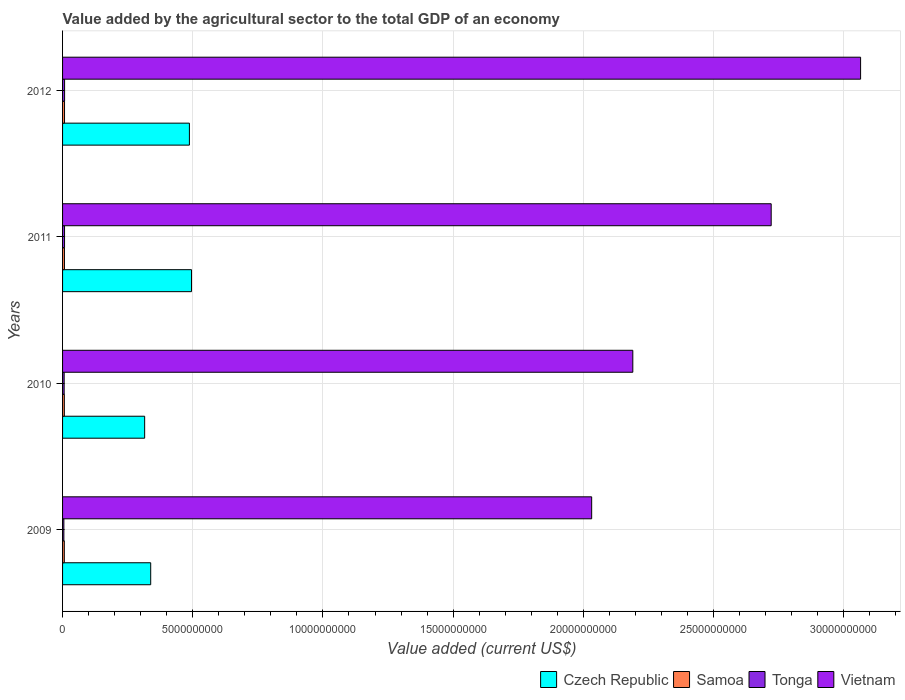How many different coloured bars are there?
Ensure brevity in your answer.  4. How many bars are there on the 3rd tick from the bottom?
Provide a succinct answer. 4. In how many cases, is the number of bars for a given year not equal to the number of legend labels?
Your response must be concise. 0. What is the value added by the agricultural sector to the total GDP in Tonga in 2012?
Offer a very short reply. 7.78e+07. Across all years, what is the maximum value added by the agricultural sector to the total GDP in Samoa?
Your answer should be very brief. 7.55e+07. Across all years, what is the minimum value added by the agricultural sector to the total GDP in Tonga?
Provide a short and direct response. 5.00e+07. In which year was the value added by the agricultural sector to the total GDP in Samoa minimum?
Give a very brief answer. 2009. What is the total value added by the agricultural sector to the total GDP in Samoa in the graph?
Your response must be concise. 2.84e+08. What is the difference between the value added by the agricultural sector to the total GDP in Vietnam in 2009 and that in 2010?
Your response must be concise. -1.58e+09. What is the difference between the value added by the agricultural sector to the total GDP in Tonga in 2010 and the value added by the agricultural sector to the total GDP in Samoa in 2009?
Your response must be concise. -5.70e+06. What is the average value added by the agricultural sector to the total GDP in Vietnam per year?
Your response must be concise. 2.50e+1. In the year 2010, what is the difference between the value added by the agricultural sector to the total GDP in Samoa and value added by the agricultural sector to the total GDP in Czech Republic?
Make the answer very short. -3.08e+09. In how many years, is the value added by the agricultural sector to the total GDP in Czech Republic greater than 23000000000 US$?
Keep it short and to the point. 0. What is the ratio of the value added by the agricultural sector to the total GDP in Vietnam in 2010 to that in 2011?
Offer a very short reply. 0.8. What is the difference between the highest and the second highest value added by the agricultural sector to the total GDP in Tonga?
Your answer should be very brief. 1.46e+06. What is the difference between the highest and the lowest value added by the agricultural sector to the total GDP in Vietnam?
Your answer should be compact. 1.03e+1. In how many years, is the value added by the agricultural sector to the total GDP in Samoa greater than the average value added by the agricultural sector to the total GDP in Samoa taken over all years?
Ensure brevity in your answer.  2. Is it the case that in every year, the sum of the value added by the agricultural sector to the total GDP in Tonga and value added by the agricultural sector to the total GDP in Vietnam is greater than the sum of value added by the agricultural sector to the total GDP in Czech Republic and value added by the agricultural sector to the total GDP in Samoa?
Your answer should be very brief. Yes. What does the 2nd bar from the top in 2012 represents?
Ensure brevity in your answer.  Tonga. What does the 2nd bar from the bottom in 2011 represents?
Offer a very short reply. Samoa. Is it the case that in every year, the sum of the value added by the agricultural sector to the total GDP in Tonga and value added by the agricultural sector to the total GDP in Czech Republic is greater than the value added by the agricultural sector to the total GDP in Vietnam?
Provide a short and direct response. No. How many bars are there?
Keep it short and to the point. 16. What is the difference between two consecutive major ticks on the X-axis?
Offer a very short reply. 5.00e+09. How many legend labels are there?
Keep it short and to the point. 4. How are the legend labels stacked?
Offer a very short reply. Horizontal. What is the title of the graph?
Provide a succinct answer. Value added by the agricultural sector to the total GDP of an economy. What is the label or title of the X-axis?
Your answer should be very brief. Value added (current US$). What is the Value added (current US$) in Czech Republic in 2009?
Your response must be concise. 3.38e+09. What is the Value added (current US$) in Samoa in 2009?
Give a very brief answer. 6.70e+07. What is the Value added (current US$) of Tonga in 2009?
Keep it short and to the point. 5.00e+07. What is the Value added (current US$) in Vietnam in 2009?
Make the answer very short. 2.03e+1. What is the Value added (current US$) in Czech Republic in 2010?
Provide a succinct answer. 3.15e+09. What is the Value added (current US$) in Samoa in 2010?
Provide a succinct answer. 6.85e+07. What is the Value added (current US$) of Tonga in 2010?
Ensure brevity in your answer.  6.13e+07. What is the Value added (current US$) in Vietnam in 2010?
Provide a succinct answer. 2.19e+1. What is the Value added (current US$) in Czech Republic in 2011?
Ensure brevity in your answer.  4.95e+09. What is the Value added (current US$) of Samoa in 2011?
Your answer should be very brief. 7.26e+07. What is the Value added (current US$) in Tonga in 2011?
Your response must be concise. 7.64e+07. What is the Value added (current US$) of Vietnam in 2011?
Your answer should be very brief. 2.72e+1. What is the Value added (current US$) in Czech Republic in 2012?
Give a very brief answer. 4.87e+09. What is the Value added (current US$) in Samoa in 2012?
Your answer should be compact. 7.55e+07. What is the Value added (current US$) in Tonga in 2012?
Ensure brevity in your answer.  7.78e+07. What is the Value added (current US$) of Vietnam in 2012?
Ensure brevity in your answer.  3.06e+1. Across all years, what is the maximum Value added (current US$) of Czech Republic?
Ensure brevity in your answer.  4.95e+09. Across all years, what is the maximum Value added (current US$) of Samoa?
Give a very brief answer. 7.55e+07. Across all years, what is the maximum Value added (current US$) in Tonga?
Provide a short and direct response. 7.78e+07. Across all years, what is the maximum Value added (current US$) of Vietnam?
Offer a very short reply. 3.06e+1. Across all years, what is the minimum Value added (current US$) of Czech Republic?
Make the answer very short. 3.15e+09. Across all years, what is the minimum Value added (current US$) in Samoa?
Keep it short and to the point. 6.70e+07. Across all years, what is the minimum Value added (current US$) of Tonga?
Provide a short and direct response. 5.00e+07. Across all years, what is the minimum Value added (current US$) in Vietnam?
Ensure brevity in your answer.  2.03e+1. What is the total Value added (current US$) in Czech Republic in the graph?
Your answer should be very brief. 1.64e+1. What is the total Value added (current US$) in Samoa in the graph?
Keep it short and to the point. 2.84e+08. What is the total Value added (current US$) in Tonga in the graph?
Provide a succinct answer. 2.66e+08. What is the total Value added (current US$) of Vietnam in the graph?
Provide a succinct answer. 1.00e+11. What is the difference between the Value added (current US$) of Czech Republic in 2009 and that in 2010?
Offer a terse response. 2.32e+08. What is the difference between the Value added (current US$) of Samoa in 2009 and that in 2010?
Provide a succinct answer. -1.42e+06. What is the difference between the Value added (current US$) of Tonga in 2009 and that in 2010?
Offer a terse response. -1.13e+07. What is the difference between the Value added (current US$) in Vietnam in 2009 and that in 2010?
Your answer should be very brief. -1.58e+09. What is the difference between the Value added (current US$) in Czech Republic in 2009 and that in 2011?
Your answer should be very brief. -1.57e+09. What is the difference between the Value added (current US$) in Samoa in 2009 and that in 2011?
Offer a very short reply. -5.52e+06. What is the difference between the Value added (current US$) of Tonga in 2009 and that in 2011?
Keep it short and to the point. -2.63e+07. What is the difference between the Value added (current US$) of Vietnam in 2009 and that in 2011?
Provide a short and direct response. -6.89e+09. What is the difference between the Value added (current US$) of Czech Republic in 2009 and that in 2012?
Your answer should be very brief. -1.49e+09. What is the difference between the Value added (current US$) of Samoa in 2009 and that in 2012?
Offer a terse response. -8.46e+06. What is the difference between the Value added (current US$) of Tonga in 2009 and that in 2012?
Your answer should be compact. -2.78e+07. What is the difference between the Value added (current US$) in Vietnam in 2009 and that in 2012?
Offer a very short reply. -1.03e+1. What is the difference between the Value added (current US$) of Czech Republic in 2010 and that in 2011?
Make the answer very short. -1.80e+09. What is the difference between the Value added (current US$) of Samoa in 2010 and that in 2011?
Give a very brief answer. -4.10e+06. What is the difference between the Value added (current US$) of Tonga in 2010 and that in 2011?
Your response must be concise. -1.50e+07. What is the difference between the Value added (current US$) of Vietnam in 2010 and that in 2011?
Give a very brief answer. -5.31e+09. What is the difference between the Value added (current US$) of Czech Republic in 2010 and that in 2012?
Provide a short and direct response. -1.72e+09. What is the difference between the Value added (current US$) in Samoa in 2010 and that in 2012?
Offer a very short reply. -7.04e+06. What is the difference between the Value added (current US$) of Tonga in 2010 and that in 2012?
Offer a terse response. -1.65e+07. What is the difference between the Value added (current US$) of Vietnam in 2010 and that in 2012?
Your answer should be compact. -8.75e+09. What is the difference between the Value added (current US$) of Czech Republic in 2011 and that in 2012?
Offer a very short reply. 8.06e+07. What is the difference between the Value added (current US$) of Samoa in 2011 and that in 2012?
Your response must be concise. -2.94e+06. What is the difference between the Value added (current US$) of Tonga in 2011 and that in 2012?
Offer a very short reply. -1.46e+06. What is the difference between the Value added (current US$) in Vietnam in 2011 and that in 2012?
Your response must be concise. -3.43e+09. What is the difference between the Value added (current US$) of Czech Republic in 2009 and the Value added (current US$) of Samoa in 2010?
Provide a short and direct response. 3.32e+09. What is the difference between the Value added (current US$) of Czech Republic in 2009 and the Value added (current US$) of Tonga in 2010?
Give a very brief answer. 3.32e+09. What is the difference between the Value added (current US$) of Czech Republic in 2009 and the Value added (current US$) of Vietnam in 2010?
Offer a very short reply. -1.85e+1. What is the difference between the Value added (current US$) of Samoa in 2009 and the Value added (current US$) of Tonga in 2010?
Ensure brevity in your answer.  5.70e+06. What is the difference between the Value added (current US$) in Samoa in 2009 and the Value added (current US$) in Vietnam in 2010?
Provide a short and direct response. -2.18e+1. What is the difference between the Value added (current US$) in Tonga in 2009 and the Value added (current US$) in Vietnam in 2010?
Provide a short and direct response. -2.19e+1. What is the difference between the Value added (current US$) of Czech Republic in 2009 and the Value added (current US$) of Samoa in 2011?
Ensure brevity in your answer.  3.31e+09. What is the difference between the Value added (current US$) in Czech Republic in 2009 and the Value added (current US$) in Tonga in 2011?
Your answer should be very brief. 3.31e+09. What is the difference between the Value added (current US$) in Czech Republic in 2009 and the Value added (current US$) in Vietnam in 2011?
Give a very brief answer. -2.38e+1. What is the difference between the Value added (current US$) of Samoa in 2009 and the Value added (current US$) of Tonga in 2011?
Keep it short and to the point. -9.34e+06. What is the difference between the Value added (current US$) in Samoa in 2009 and the Value added (current US$) in Vietnam in 2011?
Provide a short and direct response. -2.71e+1. What is the difference between the Value added (current US$) in Tonga in 2009 and the Value added (current US$) in Vietnam in 2011?
Give a very brief answer. -2.72e+1. What is the difference between the Value added (current US$) in Czech Republic in 2009 and the Value added (current US$) in Samoa in 2012?
Provide a succinct answer. 3.31e+09. What is the difference between the Value added (current US$) of Czech Republic in 2009 and the Value added (current US$) of Tonga in 2012?
Ensure brevity in your answer.  3.31e+09. What is the difference between the Value added (current US$) in Czech Republic in 2009 and the Value added (current US$) in Vietnam in 2012?
Offer a terse response. -2.73e+1. What is the difference between the Value added (current US$) in Samoa in 2009 and the Value added (current US$) in Tonga in 2012?
Keep it short and to the point. -1.08e+07. What is the difference between the Value added (current US$) in Samoa in 2009 and the Value added (current US$) in Vietnam in 2012?
Give a very brief answer. -3.06e+1. What is the difference between the Value added (current US$) of Tonga in 2009 and the Value added (current US$) of Vietnam in 2012?
Make the answer very short. -3.06e+1. What is the difference between the Value added (current US$) of Czech Republic in 2010 and the Value added (current US$) of Samoa in 2011?
Make the answer very short. 3.08e+09. What is the difference between the Value added (current US$) of Czech Republic in 2010 and the Value added (current US$) of Tonga in 2011?
Keep it short and to the point. 3.08e+09. What is the difference between the Value added (current US$) of Czech Republic in 2010 and the Value added (current US$) of Vietnam in 2011?
Your response must be concise. -2.41e+1. What is the difference between the Value added (current US$) in Samoa in 2010 and the Value added (current US$) in Tonga in 2011?
Keep it short and to the point. -7.92e+06. What is the difference between the Value added (current US$) in Samoa in 2010 and the Value added (current US$) in Vietnam in 2011?
Give a very brief answer. -2.71e+1. What is the difference between the Value added (current US$) of Tonga in 2010 and the Value added (current US$) of Vietnam in 2011?
Your answer should be compact. -2.72e+1. What is the difference between the Value added (current US$) of Czech Republic in 2010 and the Value added (current US$) of Samoa in 2012?
Ensure brevity in your answer.  3.08e+09. What is the difference between the Value added (current US$) of Czech Republic in 2010 and the Value added (current US$) of Tonga in 2012?
Make the answer very short. 3.08e+09. What is the difference between the Value added (current US$) in Czech Republic in 2010 and the Value added (current US$) in Vietnam in 2012?
Offer a terse response. -2.75e+1. What is the difference between the Value added (current US$) in Samoa in 2010 and the Value added (current US$) in Tonga in 2012?
Give a very brief answer. -9.39e+06. What is the difference between the Value added (current US$) of Samoa in 2010 and the Value added (current US$) of Vietnam in 2012?
Keep it short and to the point. -3.06e+1. What is the difference between the Value added (current US$) of Tonga in 2010 and the Value added (current US$) of Vietnam in 2012?
Your answer should be very brief. -3.06e+1. What is the difference between the Value added (current US$) of Czech Republic in 2011 and the Value added (current US$) of Samoa in 2012?
Offer a terse response. 4.88e+09. What is the difference between the Value added (current US$) of Czech Republic in 2011 and the Value added (current US$) of Tonga in 2012?
Provide a succinct answer. 4.87e+09. What is the difference between the Value added (current US$) in Czech Republic in 2011 and the Value added (current US$) in Vietnam in 2012?
Provide a succinct answer. -2.57e+1. What is the difference between the Value added (current US$) of Samoa in 2011 and the Value added (current US$) of Tonga in 2012?
Make the answer very short. -5.28e+06. What is the difference between the Value added (current US$) in Samoa in 2011 and the Value added (current US$) in Vietnam in 2012?
Keep it short and to the point. -3.06e+1. What is the difference between the Value added (current US$) of Tonga in 2011 and the Value added (current US$) of Vietnam in 2012?
Ensure brevity in your answer.  -3.06e+1. What is the average Value added (current US$) of Czech Republic per year?
Ensure brevity in your answer.  4.09e+09. What is the average Value added (current US$) of Samoa per year?
Give a very brief answer. 7.09e+07. What is the average Value added (current US$) of Tonga per year?
Offer a very short reply. 6.64e+07. What is the average Value added (current US$) of Vietnam per year?
Offer a terse response. 2.50e+1. In the year 2009, what is the difference between the Value added (current US$) of Czech Republic and Value added (current US$) of Samoa?
Keep it short and to the point. 3.32e+09. In the year 2009, what is the difference between the Value added (current US$) in Czech Republic and Value added (current US$) in Tonga?
Your answer should be very brief. 3.33e+09. In the year 2009, what is the difference between the Value added (current US$) in Czech Republic and Value added (current US$) in Vietnam?
Your answer should be compact. -1.69e+1. In the year 2009, what is the difference between the Value added (current US$) in Samoa and Value added (current US$) in Tonga?
Provide a short and direct response. 1.70e+07. In the year 2009, what is the difference between the Value added (current US$) in Samoa and Value added (current US$) in Vietnam?
Make the answer very short. -2.03e+1. In the year 2009, what is the difference between the Value added (current US$) of Tonga and Value added (current US$) of Vietnam?
Your answer should be very brief. -2.03e+1. In the year 2010, what is the difference between the Value added (current US$) of Czech Republic and Value added (current US$) of Samoa?
Give a very brief answer. 3.08e+09. In the year 2010, what is the difference between the Value added (current US$) in Czech Republic and Value added (current US$) in Tonga?
Give a very brief answer. 3.09e+09. In the year 2010, what is the difference between the Value added (current US$) in Czech Republic and Value added (current US$) in Vietnam?
Give a very brief answer. -1.87e+1. In the year 2010, what is the difference between the Value added (current US$) of Samoa and Value added (current US$) of Tonga?
Provide a short and direct response. 7.11e+06. In the year 2010, what is the difference between the Value added (current US$) in Samoa and Value added (current US$) in Vietnam?
Offer a terse response. -2.18e+1. In the year 2010, what is the difference between the Value added (current US$) in Tonga and Value added (current US$) in Vietnam?
Your response must be concise. -2.18e+1. In the year 2011, what is the difference between the Value added (current US$) in Czech Republic and Value added (current US$) in Samoa?
Give a very brief answer. 4.88e+09. In the year 2011, what is the difference between the Value added (current US$) in Czech Republic and Value added (current US$) in Tonga?
Provide a succinct answer. 4.88e+09. In the year 2011, what is the difference between the Value added (current US$) in Czech Republic and Value added (current US$) in Vietnam?
Your answer should be compact. -2.23e+1. In the year 2011, what is the difference between the Value added (current US$) in Samoa and Value added (current US$) in Tonga?
Your answer should be compact. -3.82e+06. In the year 2011, what is the difference between the Value added (current US$) in Samoa and Value added (current US$) in Vietnam?
Offer a very short reply. -2.71e+1. In the year 2011, what is the difference between the Value added (current US$) of Tonga and Value added (current US$) of Vietnam?
Your answer should be very brief. -2.71e+1. In the year 2012, what is the difference between the Value added (current US$) of Czech Republic and Value added (current US$) of Samoa?
Keep it short and to the point. 4.80e+09. In the year 2012, what is the difference between the Value added (current US$) of Czech Republic and Value added (current US$) of Tonga?
Offer a very short reply. 4.79e+09. In the year 2012, what is the difference between the Value added (current US$) of Czech Republic and Value added (current US$) of Vietnam?
Provide a succinct answer. -2.58e+1. In the year 2012, what is the difference between the Value added (current US$) in Samoa and Value added (current US$) in Tonga?
Keep it short and to the point. -2.34e+06. In the year 2012, what is the difference between the Value added (current US$) of Samoa and Value added (current US$) of Vietnam?
Your response must be concise. -3.06e+1. In the year 2012, what is the difference between the Value added (current US$) of Tonga and Value added (current US$) of Vietnam?
Your response must be concise. -3.06e+1. What is the ratio of the Value added (current US$) in Czech Republic in 2009 to that in 2010?
Provide a short and direct response. 1.07. What is the ratio of the Value added (current US$) in Samoa in 2009 to that in 2010?
Keep it short and to the point. 0.98. What is the ratio of the Value added (current US$) in Tonga in 2009 to that in 2010?
Ensure brevity in your answer.  0.82. What is the ratio of the Value added (current US$) in Vietnam in 2009 to that in 2010?
Offer a very short reply. 0.93. What is the ratio of the Value added (current US$) of Czech Republic in 2009 to that in 2011?
Give a very brief answer. 0.68. What is the ratio of the Value added (current US$) in Samoa in 2009 to that in 2011?
Offer a terse response. 0.92. What is the ratio of the Value added (current US$) in Tonga in 2009 to that in 2011?
Your response must be concise. 0.66. What is the ratio of the Value added (current US$) of Vietnam in 2009 to that in 2011?
Offer a terse response. 0.75. What is the ratio of the Value added (current US$) of Czech Republic in 2009 to that in 2012?
Make the answer very short. 0.69. What is the ratio of the Value added (current US$) in Samoa in 2009 to that in 2012?
Your answer should be compact. 0.89. What is the ratio of the Value added (current US$) of Tonga in 2009 to that in 2012?
Your answer should be compact. 0.64. What is the ratio of the Value added (current US$) of Vietnam in 2009 to that in 2012?
Provide a succinct answer. 0.66. What is the ratio of the Value added (current US$) in Czech Republic in 2010 to that in 2011?
Your response must be concise. 0.64. What is the ratio of the Value added (current US$) in Samoa in 2010 to that in 2011?
Your answer should be compact. 0.94. What is the ratio of the Value added (current US$) in Tonga in 2010 to that in 2011?
Offer a very short reply. 0.8. What is the ratio of the Value added (current US$) in Vietnam in 2010 to that in 2011?
Provide a short and direct response. 0.8. What is the ratio of the Value added (current US$) in Czech Republic in 2010 to that in 2012?
Your answer should be compact. 0.65. What is the ratio of the Value added (current US$) in Samoa in 2010 to that in 2012?
Provide a succinct answer. 0.91. What is the ratio of the Value added (current US$) in Tonga in 2010 to that in 2012?
Your answer should be compact. 0.79. What is the ratio of the Value added (current US$) of Vietnam in 2010 to that in 2012?
Offer a terse response. 0.71. What is the ratio of the Value added (current US$) of Czech Republic in 2011 to that in 2012?
Keep it short and to the point. 1.02. What is the ratio of the Value added (current US$) of Samoa in 2011 to that in 2012?
Your answer should be compact. 0.96. What is the ratio of the Value added (current US$) of Tonga in 2011 to that in 2012?
Provide a short and direct response. 0.98. What is the ratio of the Value added (current US$) in Vietnam in 2011 to that in 2012?
Keep it short and to the point. 0.89. What is the difference between the highest and the second highest Value added (current US$) in Czech Republic?
Ensure brevity in your answer.  8.06e+07. What is the difference between the highest and the second highest Value added (current US$) in Samoa?
Your response must be concise. 2.94e+06. What is the difference between the highest and the second highest Value added (current US$) of Tonga?
Ensure brevity in your answer.  1.46e+06. What is the difference between the highest and the second highest Value added (current US$) in Vietnam?
Your answer should be compact. 3.43e+09. What is the difference between the highest and the lowest Value added (current US$) in Czech Republic?
Provide a succinct answer. 1.80e+09. What is the difference between the highest and the lowest Value added (current US$) in Samoa?
Offer a very short reply. 8.46e+06. What is the difference between the highest and the lowest Value added (current US$) in Tonga?
Your answer should be very brief. 2.78e+07. What is the difference between the highest and the lowest Value added (current US$) of Vietnam?
Offer a very short reply. 1.03e+1. 